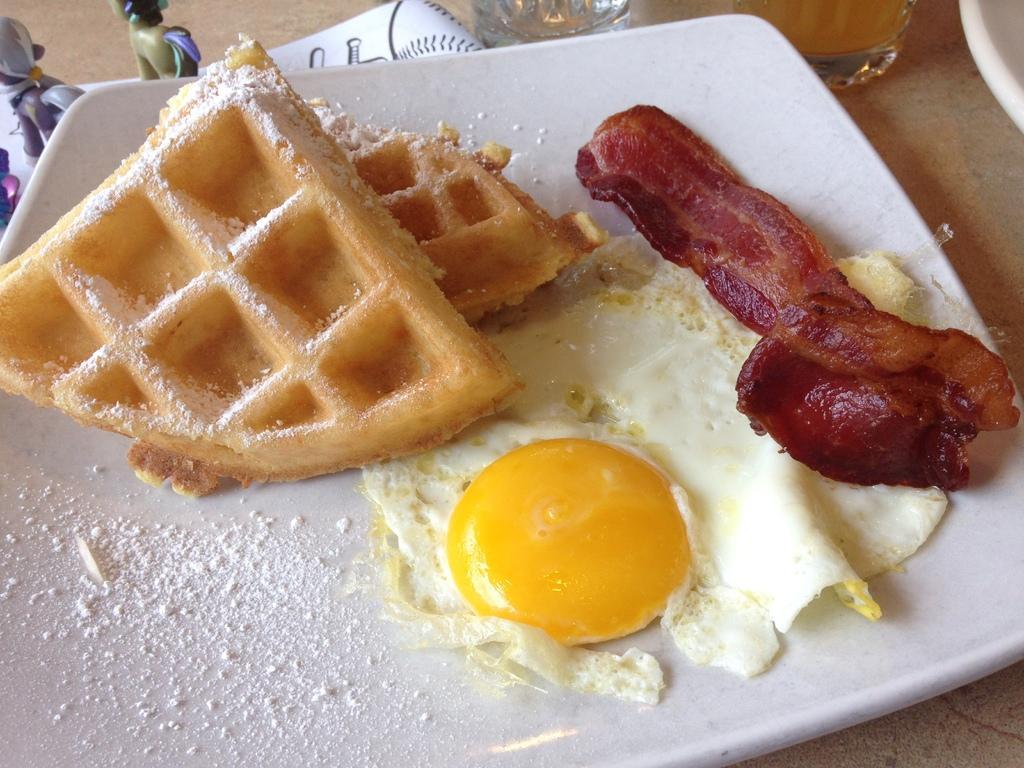In one or two sentences, can you explain what this image depicts? In this picture I can see a white plate in front, on which there are waffles, yolk and a red and brown color food and I see the white color powder. On the left corner of this image I see toys. On the top of this image I see the glasses. 